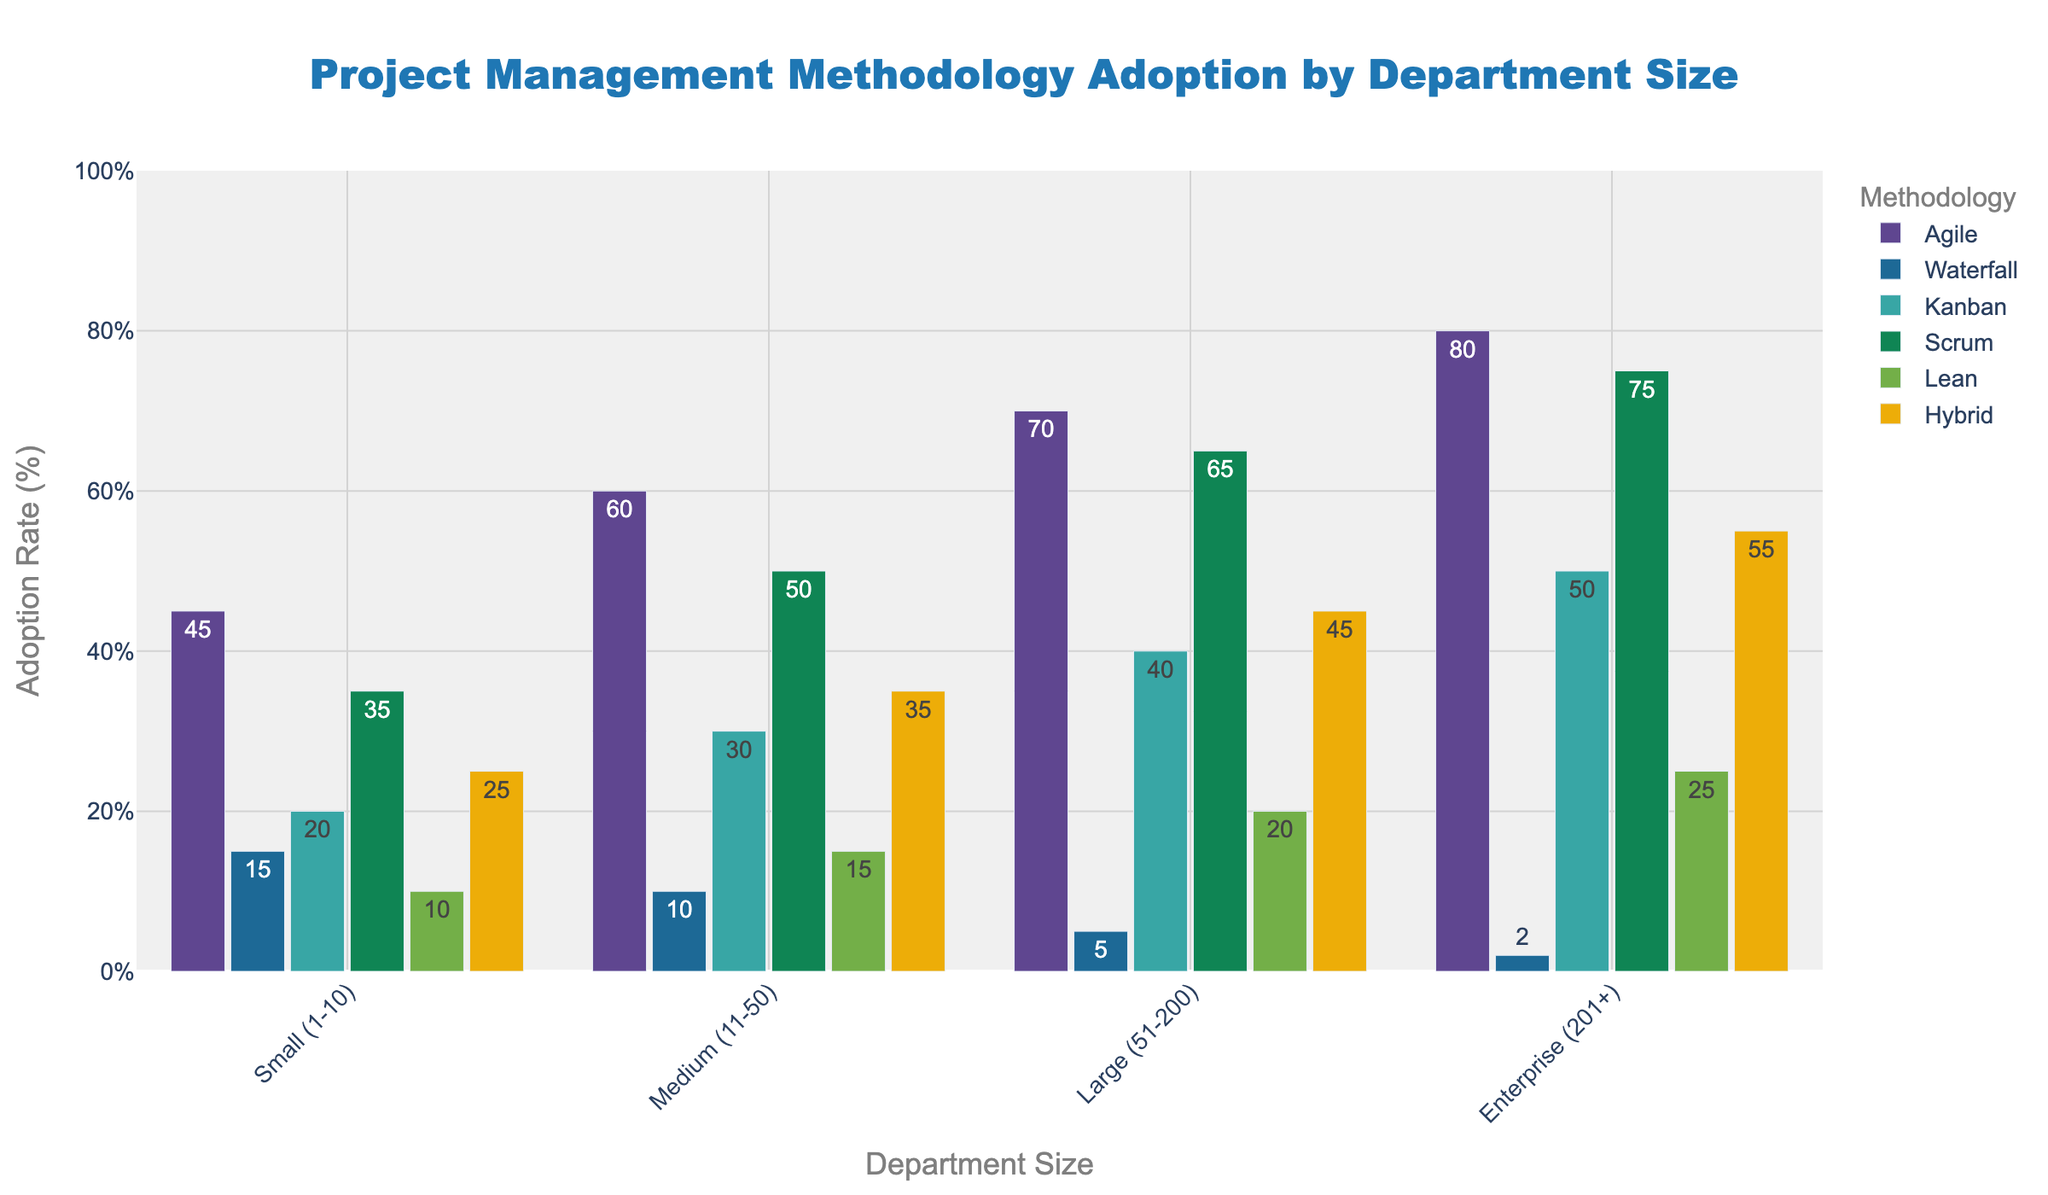Which project management methodology has the highest adoption rate in the "Medium (11-50)" department size? By looking at the bar heights for each methodology within the "Medium (11-50)" department size, the highest bar is for Agile at 60%.
Answer: Agile By how much does the adoption rate of Scrum in "Enterprise (201+)" departments surpass that in "Small (1-10)" departments? The adoption rate of Scrum in "Enterprise (201+)" departments is 75% and in "Small (1-10)" departments is 35%. Subtracting these gives 75% - 35%.
Answer: 40% Which methodology is least adopted in "Large (51-200)" departments? Observing the bar heights for "Large (51-200)" departments, Waterfall has the shortest bar, indicating the lowest percentage.
Answer: Waterfall How does the adoption rate of Kanban compare between "Small (1-10)" and "Large (51-200)" departments? The adoption rate of Kanban is 20% for "Small (1-10)" departments and 40% for "Large (51-200)" departments. The rate in "Large (51-200)" is higher.
Answer: Large (51-200) What is the combined adoption rate of Agile and Lean in "Enterprise (201+)" departments? The adoption rates for Agile and Lean in "Enterprise (201+)" departments are 80% and 25%, respectively. Adding these gives 80% + 25%.
Answer: 105% What is the visual difference between the adoption rates of Hybrid in "Small (1-10)" and "Medium (11-50)" departments? The height of the Hybrid bar is higher in "Medium (11-50)" (35%) compared to "Small (1-10)" (25%).
Answer: Higher Which department size shows the most diverse adoption rates across different methodologies? Observing the bar heights across methodologies for each department size, "Enterprise (201+)" shows the most variance, ranging from 2% to 80%.
Answer: Enterprise (201+) What is the average adoption rate of Waterfall across all department sizes? Waterfall adoption rates are 15%, 10%, 5%, and 2% for each respective department size. The average is calculated by (15 + 10 + 5 + 2) / 4.
Answer: 8% By how much does the adoption rate of Lean in "Medium (11-50)" departments differ from that in "Enterprise (201+)" departments? The adoption rate of Lean is 15% in "Medium (11-50)" and 25% in "Enterprise (201+)". The difference is 25% - 15%.
Answer: 10% Which methodology shows a consistent increase in adoption rate as the department size increases? By comparing bar heights for each methodology across increasing department sizes, Agile consistently rises from 45%, 60%, 70%, to 80%.
Answer: Agile 